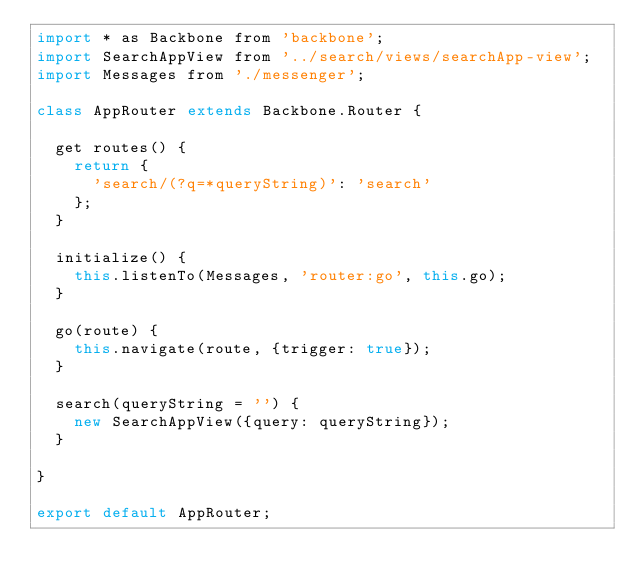<code> <loc_0><loc_0><loc_500><loc_500><_JavaScript_>import * as Backbone from 'backbone';
import SearchAppView from '../search/views/searchApp-view';
import Messages from './messenger';

class AppRouter extends Backbone.Router {

  get routes() {
    return {
      'search/(?q=*queryString)': 'search'
    };
  }

  initialize() {
    this.listenTo(Messages, 'router:go', this.go);
  }

  go(route) {
    this.navigate(route, {trigger: true});
  }

  search(queryString = '') {
    new SearchAppView({query: queryString});
  }

}

export default AppRouter;
</code> 